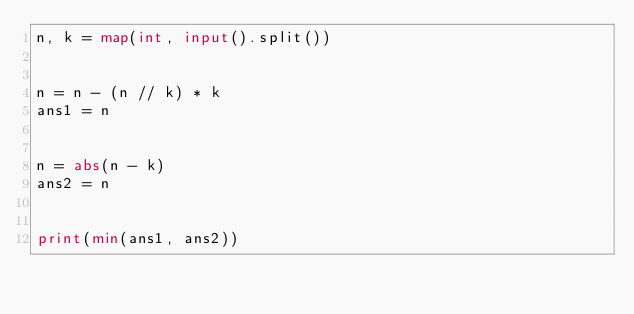<code> <loc_0><loc_0><loc_500><loc_500><_Python_>n, k = map(int, input().split())


n = n - (n // k) * k
ans1 = n


n = abs(n - k)
ans2 = n


print(min(ans1, ans2))
</code> 